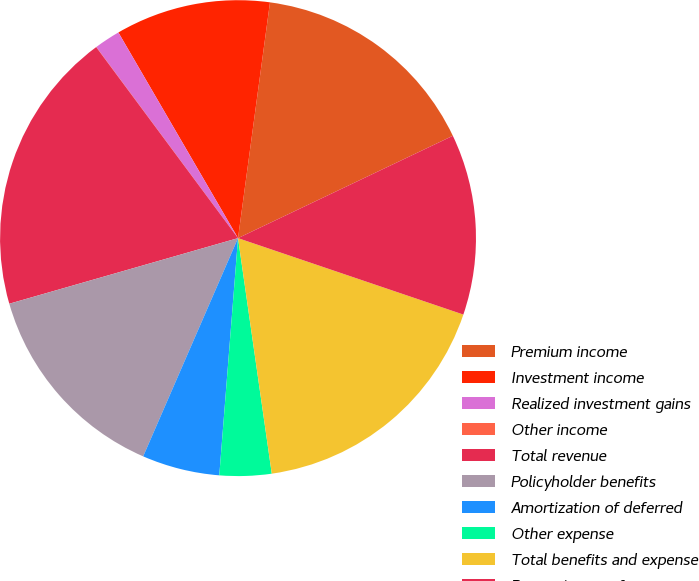Convert chart to OTSL. <chart><loc_0><loc_0><loc_500><loc_500><pie_chart><fcel>Premium income<fcel>Investment income<fcel>Realized investment gains<fcel>Other income<fcel>Total revenue<fcel>Policyholder benefits<fcel>Amortization of deferred<fcel>Other expense<fcel>Total benefits and expense<fcel>Pre tax income from<nl><fcel>15.78%<fcel>10.53%<fcel>1.77%<fcel>0.01%<fcel>19.28%<fcel>14.03%<fcel>5.27%<fcel>3.52%<fcel>17.53%<fcel>12.28%<nl></chart> 